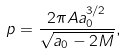Convert formula to latex. <formula><loc_0><loc_0><loc_500><loc_500>p = \frac { 2 \pi A a _ { 0 } ^ { 3 / 2 } } { \sqrt { a _ { 0 } - 2 M } } ,</formula> 